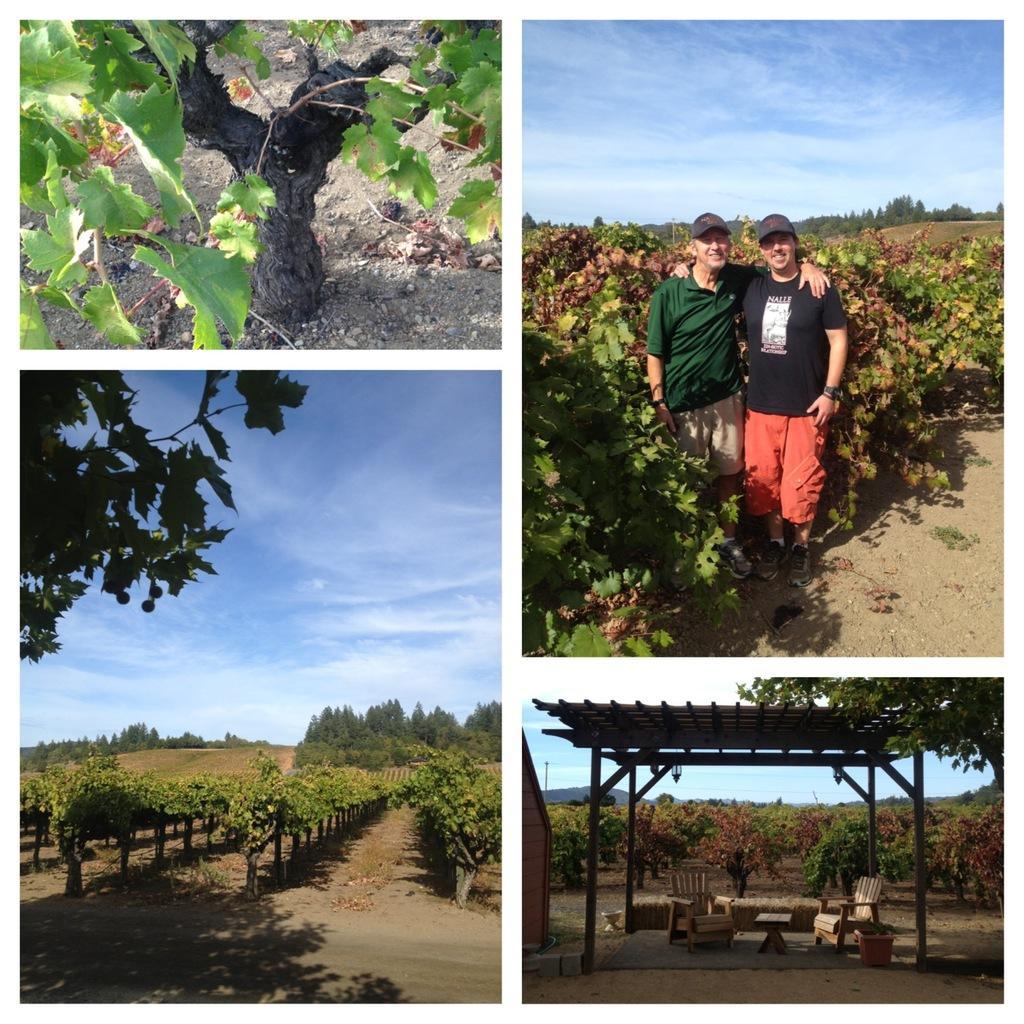How would you summarize this image in a sentence or two? In the picture I can see four images. In the first image I can see a plant. In the second picture, we can see two persons wearing T-shirts and caps are standing near the plants, in the background, we can see trees and the blue color sky with clouds. In the third picture we can see the plants, trees and the blue color sky with clouds. In the fourth picture we can see the pergola, chairs and table and in the background, we can see the plants, trees and the sky. 